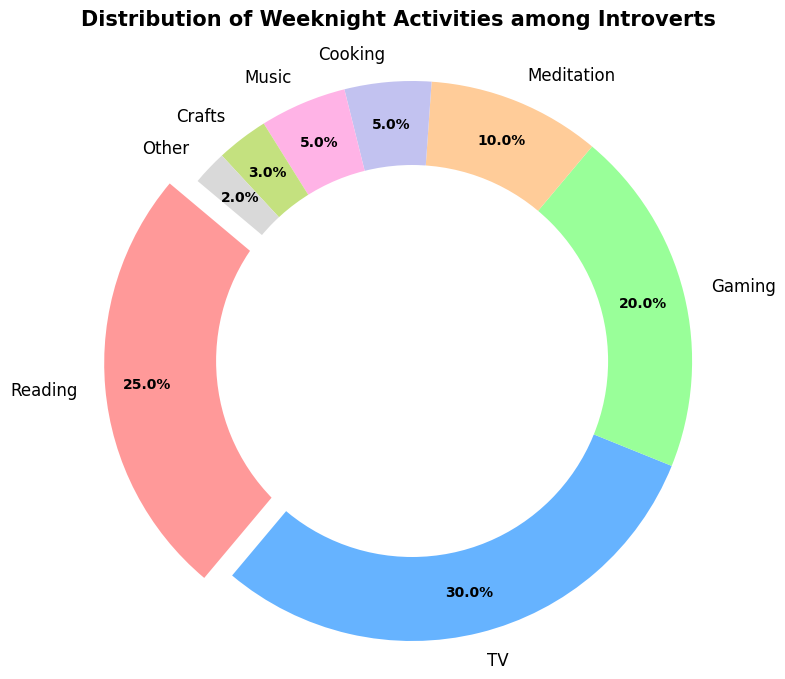What percentage of introverts prefer watching TV on weeknights? According to the figure, the section labeled 'TV' represents 30% of the chart.
Answer: 30% Which activities make up more than 20% of the chart combined? Adding the percentages of activities with over 20%: Reading (25%), TV (30%), and Gaming (20%). Together, these total 75%.
Answer: Reading, TV, and Gaming Is reading a more popular weeknight activity than gaming among introverts? The chart shows that reading is 25%, while gaming is 20%. Hence, reading is more popular.
Answer: Yes Among meditation, cooking, and music, which activity has the least percentage? Meditation is 10%, cooking is 5%, and music is 5%. 'Other' is lower than all at 2%, but it isn't among the listed activities. Cooking and music have the least percentage compared to meditation.
Answer: Cooking and music What is the total percentage for activities categorized as 'Other'? The slice labeled 'Other' indicates this category accounts for 2% of the total weeknight activities.
Answer: 2% How many percentage points more is watching TV compared to meditation? TV is 30%, and meditation is 10%. So, TV is 30% - 10% = 20% more than meditation.
Answer: 20% What color represents the 'Crafts' activity on the chart? The chart shows 'Crafts' in a segment with a specific color. According to the order, 'Crafts' is represented by a greenish-yellow segment.
Answer: Greenish-yellow Which segment is exploded out of the ring, and what activity does it represent? The exploded segment is the one that stands out from the rest of the ring, representing 'Reading'.
Answer: Reading What is the combined percentage of activities that are less than or equal to 5% each? Summing the segments for Cooking (5%), Music (5%), Crafts (3%), and Other (2%): 5% + 5% + 3% + 2% = 15%.
Answer: 15% Considering all activities, which one is visually presented with the largest segment on the ring chart? The largest segment is labeled as 'TV', which occupies the largest part of the ring.
Answer: TV 